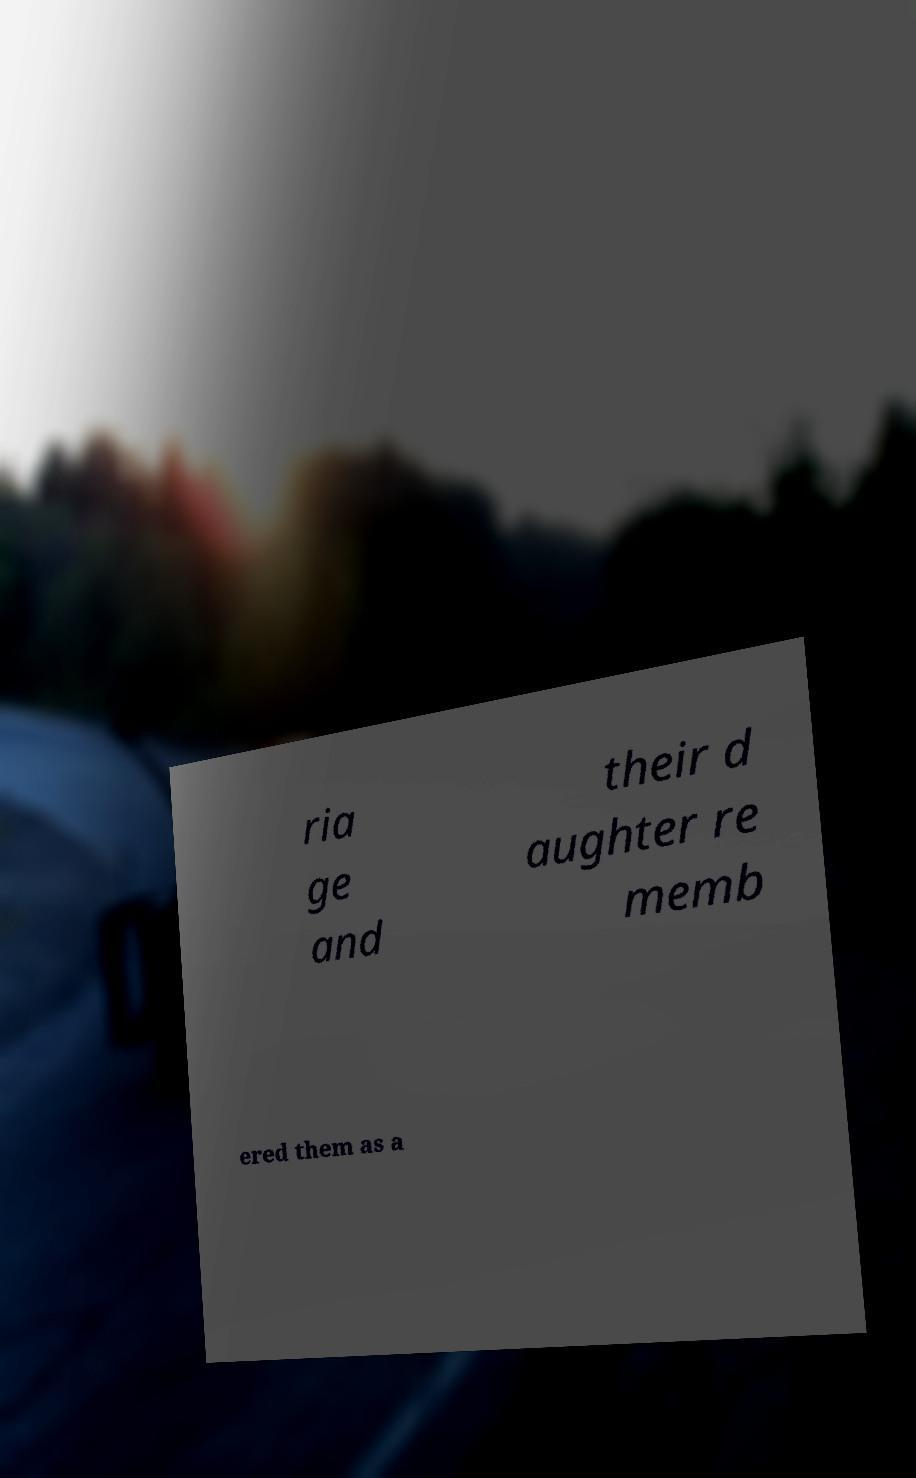Can you accurately transcribe the text from the provided image for me? ria ge and their d aughter re memb ered them as a 